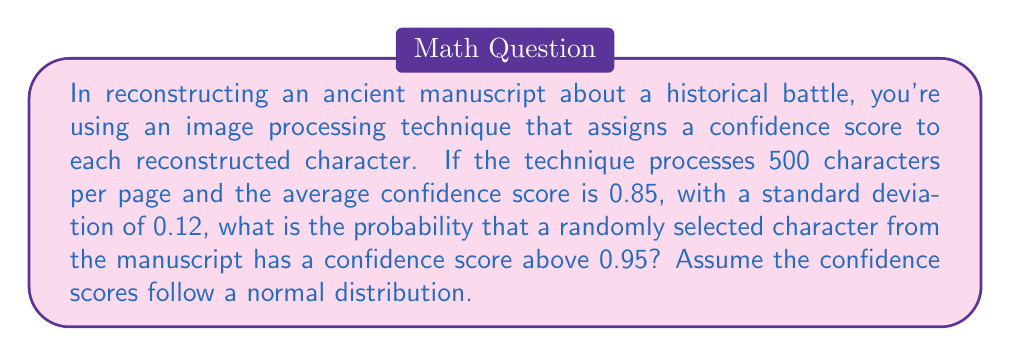Can you solve this math problem? Let's approach this step-by-step:

1) We're given:
   - Mean (μ) = 0.85
   - Standard deviation (σ) = 0.12
   - We want to find P(X > 0.95), where X is the confidence score

2) To solve this, we need to calculate the z-score for 0.95:

   $$z = \frac{x - \mu}{\sigma}$$

   Where x is our value of interest (0.95)

3) Plugging in the values:

   $$z = \frac{0.95 - 0.85}{0.12} = \frac{0.10}{0.12} = 0.8333$$

4) Now we need to find the probability of a z-score greater than 0.8333.

5) Using a standard normal distribution table or calculator, we find:

   P(Z > 0.8333) ≈ 0.2023

6) Therefore, the probability of a randomly selected character having a confidence score above 0.95 is approximately 0.2023 or 20.23%.

This problem relates to the persona's interest in historical fiction by framing the question in the context of reconstructing an ancient manuscript about a historical battle, which could be a source for a captivating historical narrative.
Answer: 0.2023 